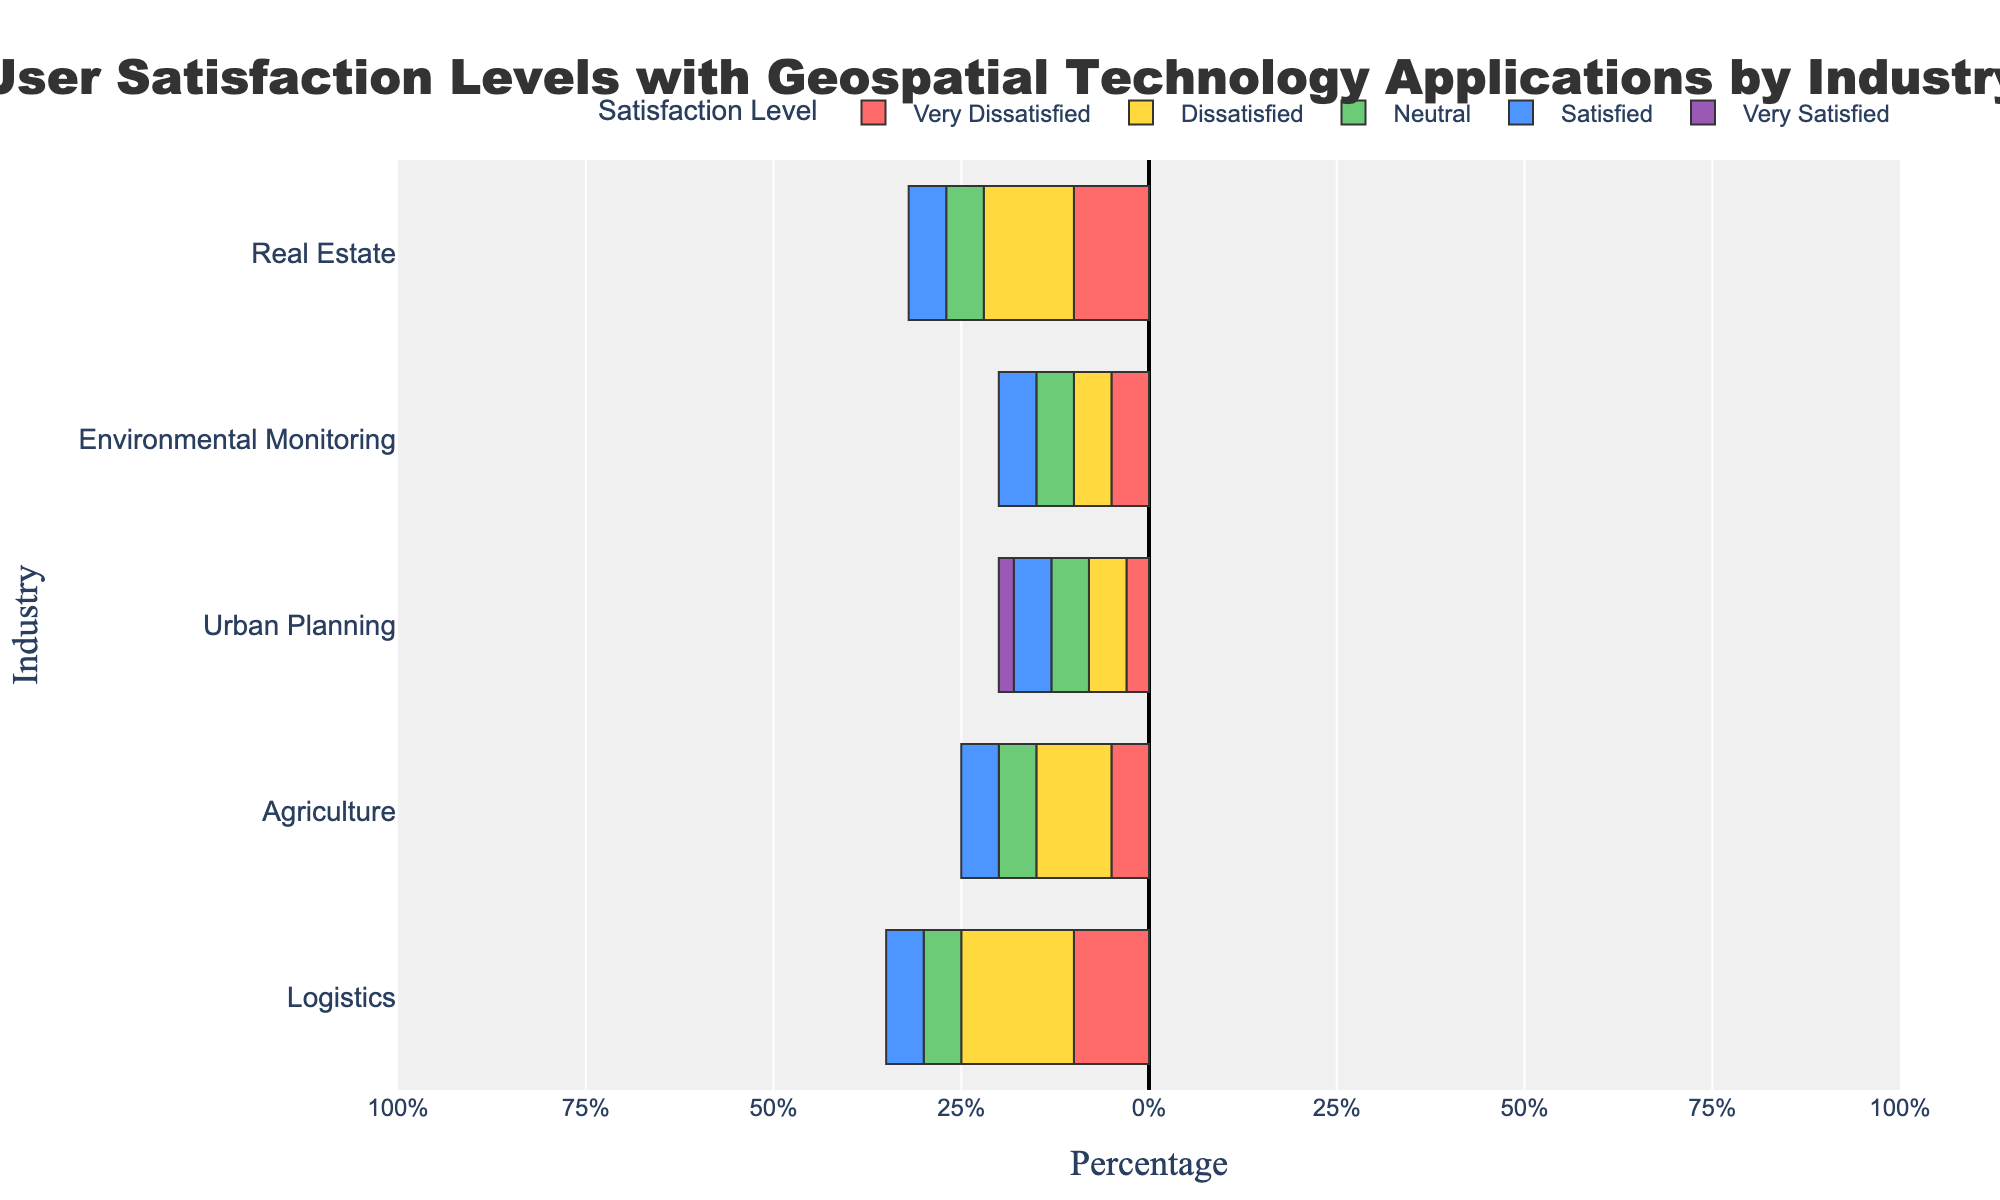What industry has the highest percentage of 'Very Satisfied' users? Look at the bars corresponding to 'Very Satisfied' for each industry and identify the bar with the greatest length. The Agriculture and Environmental Monitoring industries have the highest percentage of 'Very Satisfied' users, both at 60%
Answer: Agriculture and Environmental Monitoring Which industry has the highest combined percentage of 'Satisfied' and 'Very Satisfied' users? Add the percentages of 'Satisfied' and 'Very Satisfied' for each industry. Compare these sums to find the highest total. For Agriculture, it is 75% (35%+40%), which is the highest among the industries.
Answer: Agriculture In the Logistics industry, what is the percentage difference between 'Very Dissatisfied' and 'Very Satisfied' users? Subtract the percentage of 'Very Dissatisfied' users (10%) from the percentage of 'Very Satisfied' users (55%) in Logistics: 55% - 10% = 45%
Answer: 45% Which industry has the lowest percentage of 'Neutral' users? Compare the 'Neutral' bars across all industries and find the bar with the lowest percentage. Urban Planning has the lowest percentage of 'Neutral' users at 20%.
Answer: Urban Planning In the Real Estate industry, what's the sum of the 'Very Dissatisfied' and 'Dissatisfied' user percentages? Add the percentages of 'Very Dissatisfied' and 'Dissatisfied' users in Real Estate: 10% + 12% = 22%
Answer: 22% Which segment in the Urban Planning industry has the smallest percentage and what is it? In Urban Planning, the 'Very Satisfied' level for 'Very Dissatisfied' users has the smallest percentage at 2%.
Answer: Very Dissatisfied - 2% How does the 'Satisfied' user percentage in the Environmental Monitoring industry compare to that in the Real Estate industry? Look at the 'Satisfied' bars for both industries and compare them. Environmental Monitoring has 30%, while Real Estate has 30%.
Answer: Equal In the Agriculture industry, what's the average percentage of users who are 'Neutral' and 'Very Dissatisfied'? Add the percentages of 'Neutral' (25%) and 'Very Dissatisfied' (5%), then divide by 2: (25% + 5%) / 2 = 15%
Answer: 15% Which industry has the longest bar section for 'Very Dissatisfied' users and what is its percentage? Identify the longest 'Very Dissatisfied' bar segment across all industries. The Logistics industry has the longest 'Very Dissatisfied' bar at 10%.
Answer: Logistics - 10% If we combine the 'Dissatisfied' and 'Very Dissatisfied' user percentages in Urban Planning, what total percentage do we get? Add the percentages of 'Very Dissatisfied' (3%) and 'Dissatisfied' (5%): 3% + 5% = 8%
Answer: 8 % 